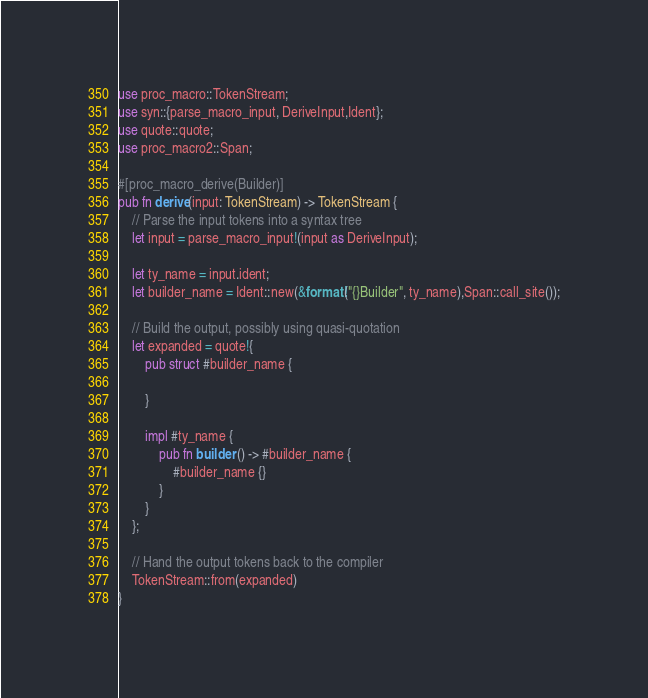<code> <loc_0><loc_0><loc_500><loc_500><_Rust_>use proc_macro::TokenStream;
use syn::{parse_macro_input, DeriveInput,Ident};
use quote::quote;
use proc_macro2::Span;

#[proc_macro_derive(Builder)]
pub fn derive(input: TokenStream) -> TokenStream {
    // Parse the input tokens into a syntax tree
    let input = parse_macro_input!(input as DeriveInput);

    let ty_name = input.ident;
    let builder_name = Ident::new(&format!("{}Builder", ty_name),Span::call_site());

    // Build the output, possibly using quasi-quotation
    let expanded = quote!{
        pub struct #builder_name {

        }

        impl #ty_name {
            pub fn builder () -> #builder_name {
                #builder_name {}
            }
        }
    };

    // Hand the output tokens back to the compiler
    TokenStream::from(expanded)
}
</code> 